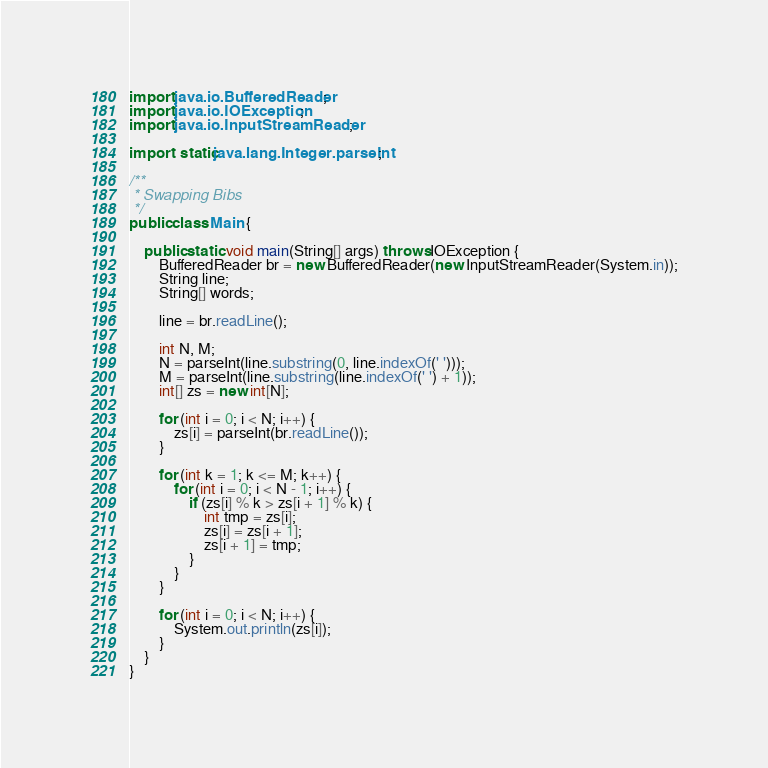Convert code to text. <code><loc_0><loc_0><loc_500><loc_500><_Java_>import java.io.BufferedReader;
import java.io.IOException;
import java.io.InputStreamReader;

import static java.lang.Integer.parseInt;

/**
 * Swapping Bibs
 */
public class Main {

	public static void main(String[] args) throws IOException {
		BufferedReader br = new BufferedReader(new InputStreamReader(System.in));
		String line;
		String[] words;

		line = br.readLine();

		int N, M;
		N = parseInt(line.substring(0, line.indexOf(' ')));
		M = parseInt(line.substring(line.indexOf(' ') + 1));
		int[] zs = new int[N];

		for (int i = 0; i < N; i++) {
			zs[i] = parseInt(br.readLine());
		}

		for (int k = 1; k <= M; k++) {
			for (int i = 0; i < N - 1; i++) {
				if (zs[i] % k > zs[i + 1] % k) {
					int tmp = zs[i];
					zs[i] = zs[i + 1];
					zs[i + 1] = tmp;
				}
			}
		}

		for (int i = 0; i < N; i++) {
			System.out.println(zs[i]);
		}
	}
}</code> 